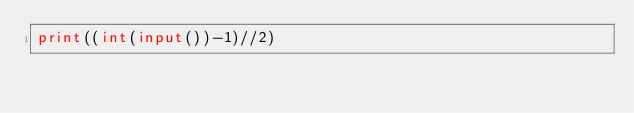<code> <loc_0><loc_0><loc_500><loc_500><_Python_>print((int(input())-1)//2)</code> 